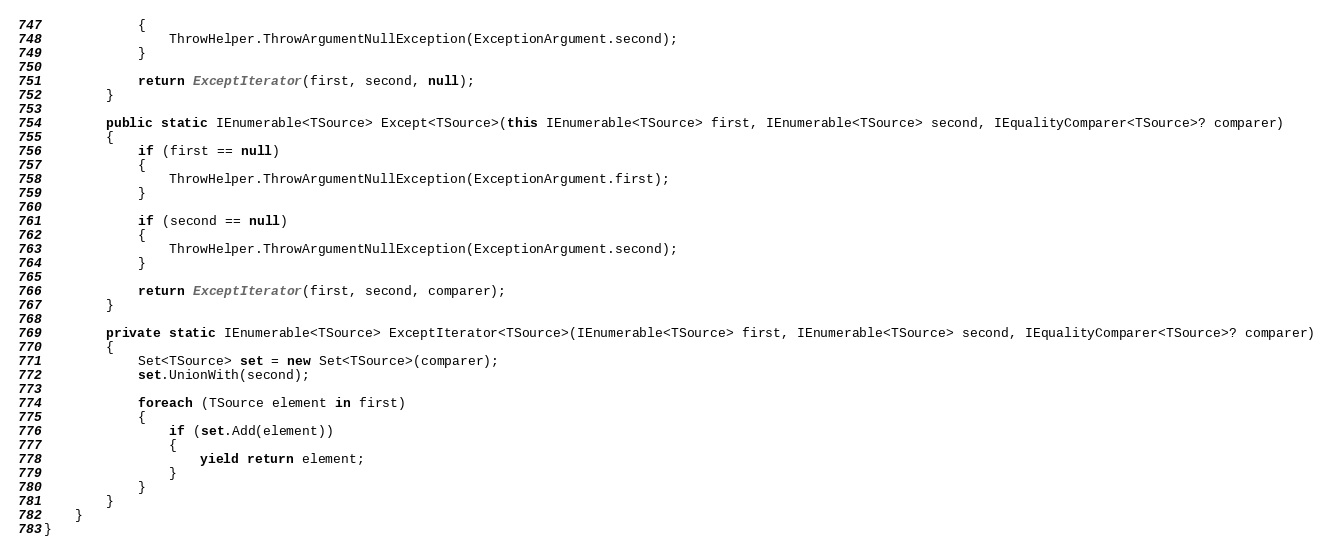Convert code to text. <code><loc_0><loc_0><loc_500><loc_500><_C#_>            {
                ThrowHelper.ThrowArgumentNullException(ExceptionArgument.second);
            }

            return ExceptIterator(first, second, null);
        }

        public static IEnumerable<TSource> Except<TSource>(this IEnumerable<TSource> first, IEnumerable<TSource> second, IEqualityComparer<TSource>? comparer)
        {
            if (first == null)
            {
                ThrowHelper.ThrowArgumentNullException(ExceptionArgument.first);
            }

            if (second == null)
            {
                ThrowHelper.ThrowArgumentNullException(ExceptionArgument.second);
            }

            return ExceptIterator(first, second, comparer);
        }

        private static IEnumerable<TSource> ExceptIterator<TSource>(IEnumerable<TSource> first, IEnumerable<TSource> second, IEqualityComparer<TSource>? comparer)
        {
            Set<TSource> set = new Set<TSource>(comparer);
            set.UnionWith(second);

            foreach (TSource element in first)
            {
                if (set.Add(element))
                {
                    yield return element;
                }
            }
        }
    }
}
</code> 